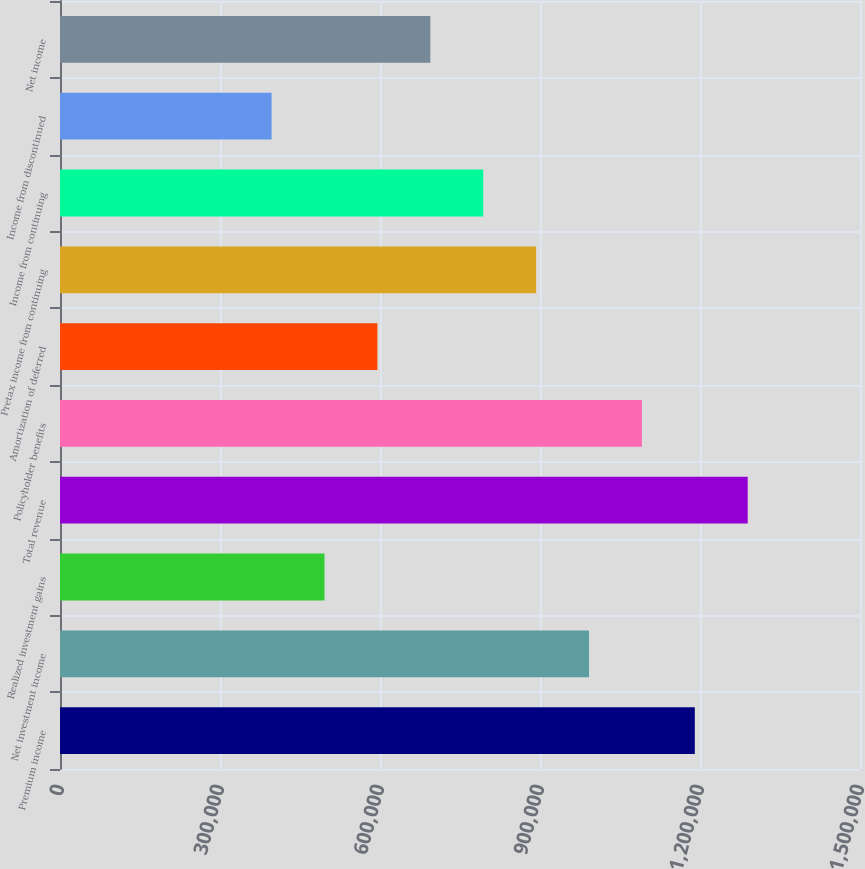Convert chart to OTSL. <chart><loc_0><loc_0><loc_500><loc_500><bar_chart><fcel>Premium income<fcel>Net investment income<fcel>Realized investment gains<fcel>Total revenue<fcel>Policyholder benefits<fcel>Amortization of deferred<fcel>Pretax income from continuing<fcel>Income from continuing<fcel>Income from discontinued<fcel>Net income<nl><fcel>1.19026e+06<fcel>991884<fcel>495942<fcel>1.28945e+06<fcel>1.09107e+06<fcel>595130<fcel>892696<fcel>793507<fcel>396754<fcel>694319<nl></chart> 